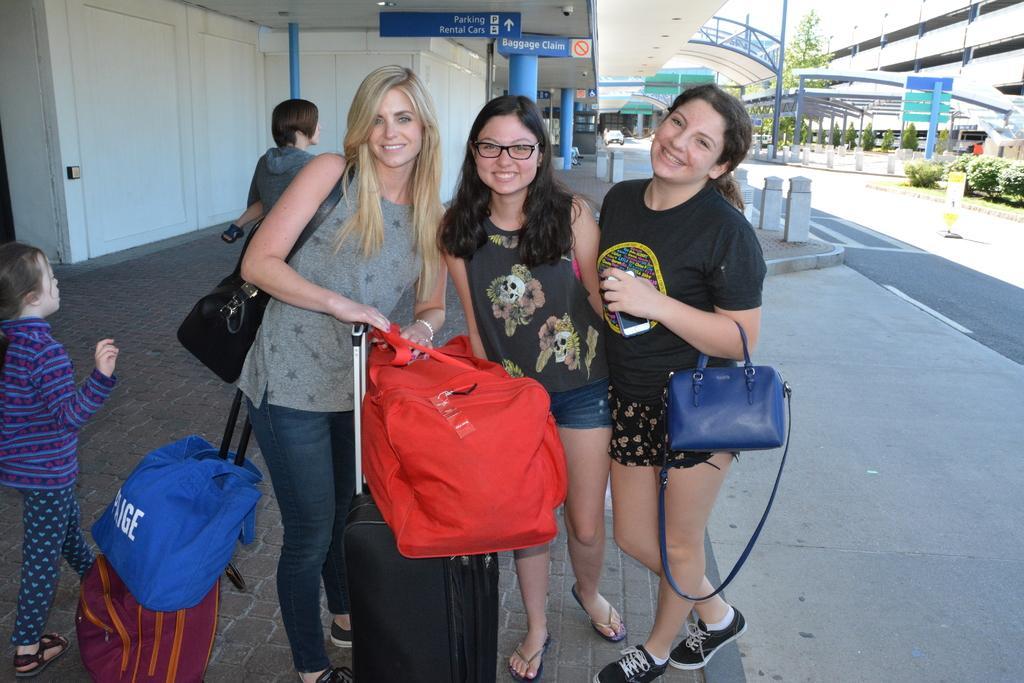Can you describe this image briefly? In this picture there are ladies in the center of the image, there is luggage at the bottom side of the image and there are plants on the right side of the image. 